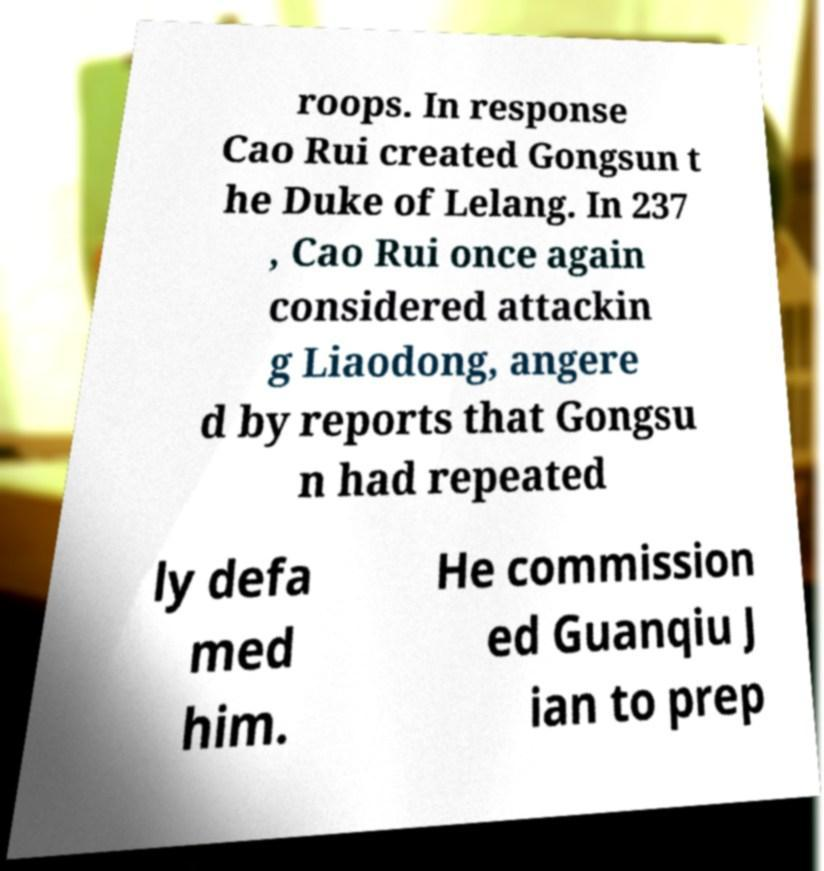Can you read and provide the text displayed in the image?This photo seems to have some interesting text. Can you extract and type it out for me? roops. In response Cao Rui created Gongsun t he Duke of Lelang. In 237 , Cao Rui once again considered attackin g Liaodong, angere d by reports that Gongsu n had repeated ly defa med him. He commission ed Guanqiu J ian to prep 